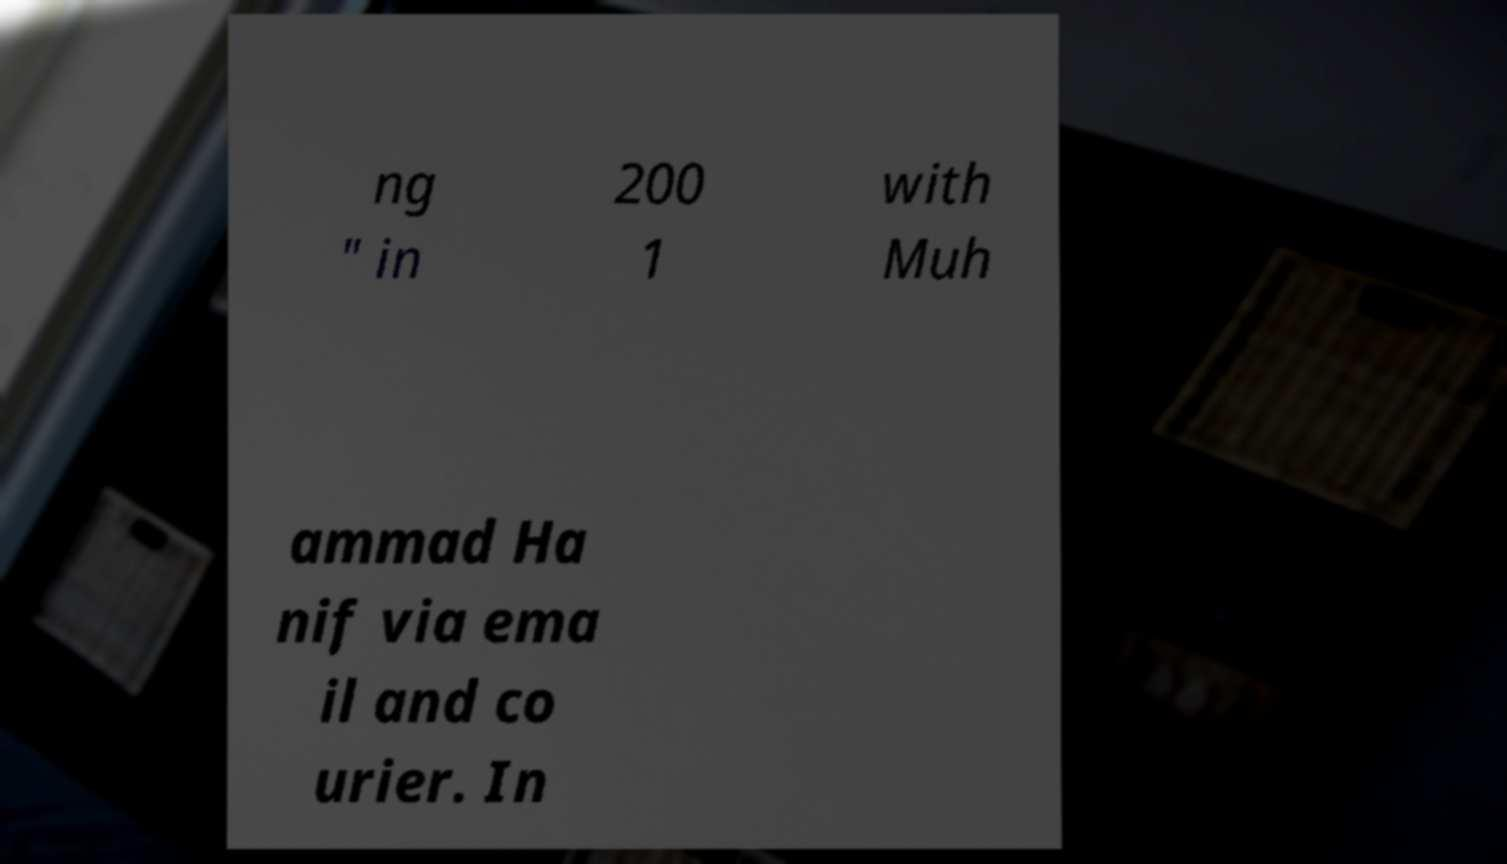Please read and relay the text visible in this image. What does it say? ng " in 200 1 with Muh ammad Ha nif via ema il and co urier. In 